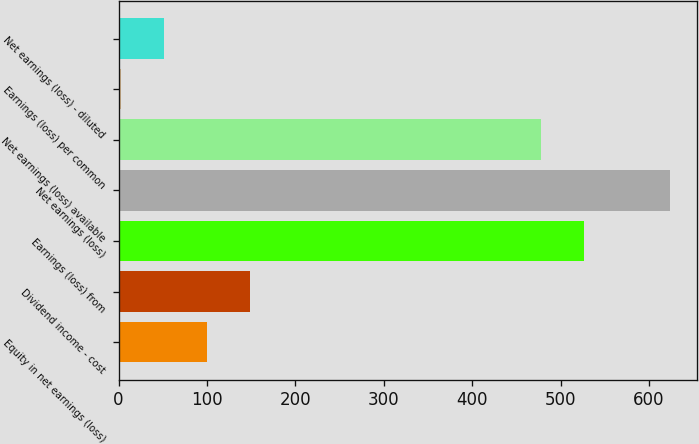<chart> <loc_0><loc_0><loc_500><loc_500><bar_chart><fcel>Equity in net earnings (loss)<fcel>Dividend income - cost<fcel>Earnings (loss) from<fcel>Net earnings (loss)<fcel>Net earnings (loss) available<fcel>Earnings (loss) per common<fcel>Net earnings (loss) - diluted<nl><fcel>100.06<fcel>148.55<fcel>526.49<fcel>623.47<fcel>478<fcel>3.08<fcel>51.57<nl></chart> 